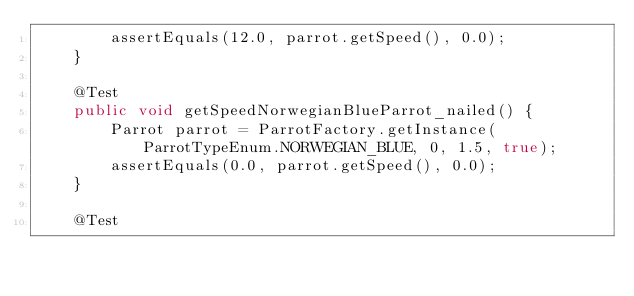Convert code to text. <code><loc_0><loc_0><loc_500><loc_500><_Java_>        assertEquals(12.0, parrot.getSpeed(), 0.0);
    }

    @Test
    public void getSpeedNorwegianBlueParrot_nailed() {
        Parrot parrot = ParrotFactory.getInstance(ParrotTypeEnum.NORWEGIAN_BLUE, 0, 1.5, true);
        assertEquals(0.0, parrot.getSpeed(), 0.0);
    }

    @Test</code> 